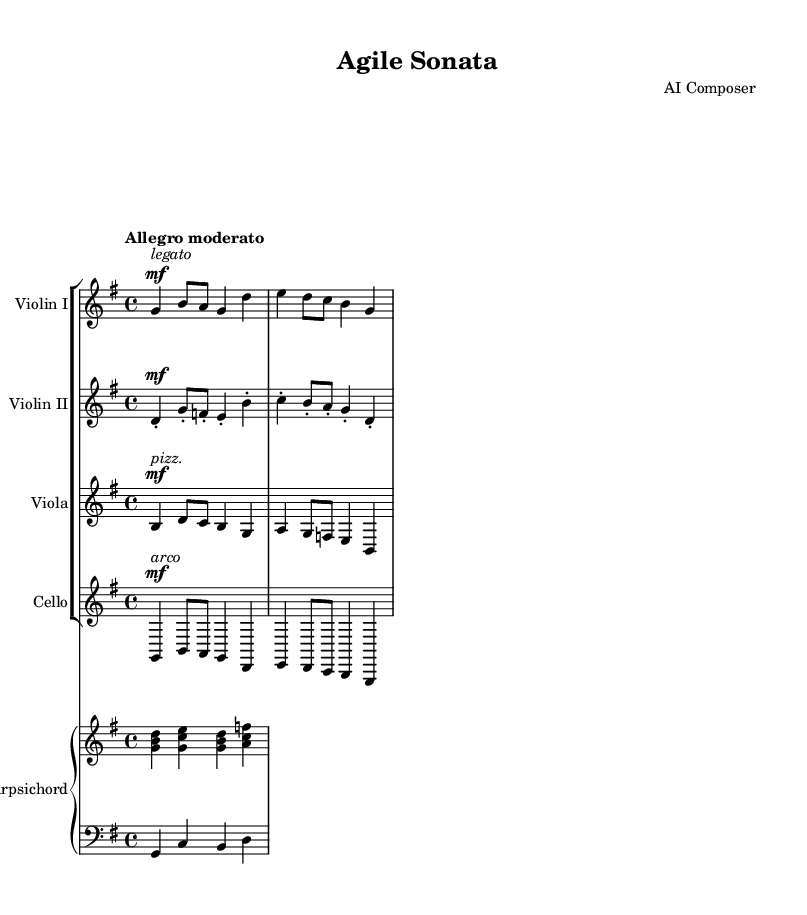What is the key signature of this music? The key signature is G major, which has one sharp (F#) indicated at the beginning of the staff.
Answer: G major What is the time signature of this music? The time signature is 4/4, as indicated in the beginning of the score, meaning there are four beats per measure.
Answer: 4/4 What is the tempo marking of the piece? The tempo marking is "Allegro moderato," which suggests a moderately fast pace for the performance.
Answer: Allegro moderato How many instruments are featured in this piece? There are five instruments featured in total: two violins, one viola, one cello, and one harpsichord.
Answer: Five Which instrument plays the pizzicato section? The viola section is marked with "pizz." indicating that it should be played pizzicato, which means plucked instead of bowed.
Answer: Viola What is the main texture of the music? The main texture is polyphonic, where multiple independent melodies are woven together, reflecting the collaborative process similar to game development teams.
Answer: Polyphonic What type of composition is this? This composition is a sonata, which is typically a chamber work that highlights individual instruments collaborating in harmony and counterpoint.
Answer: Sonata 